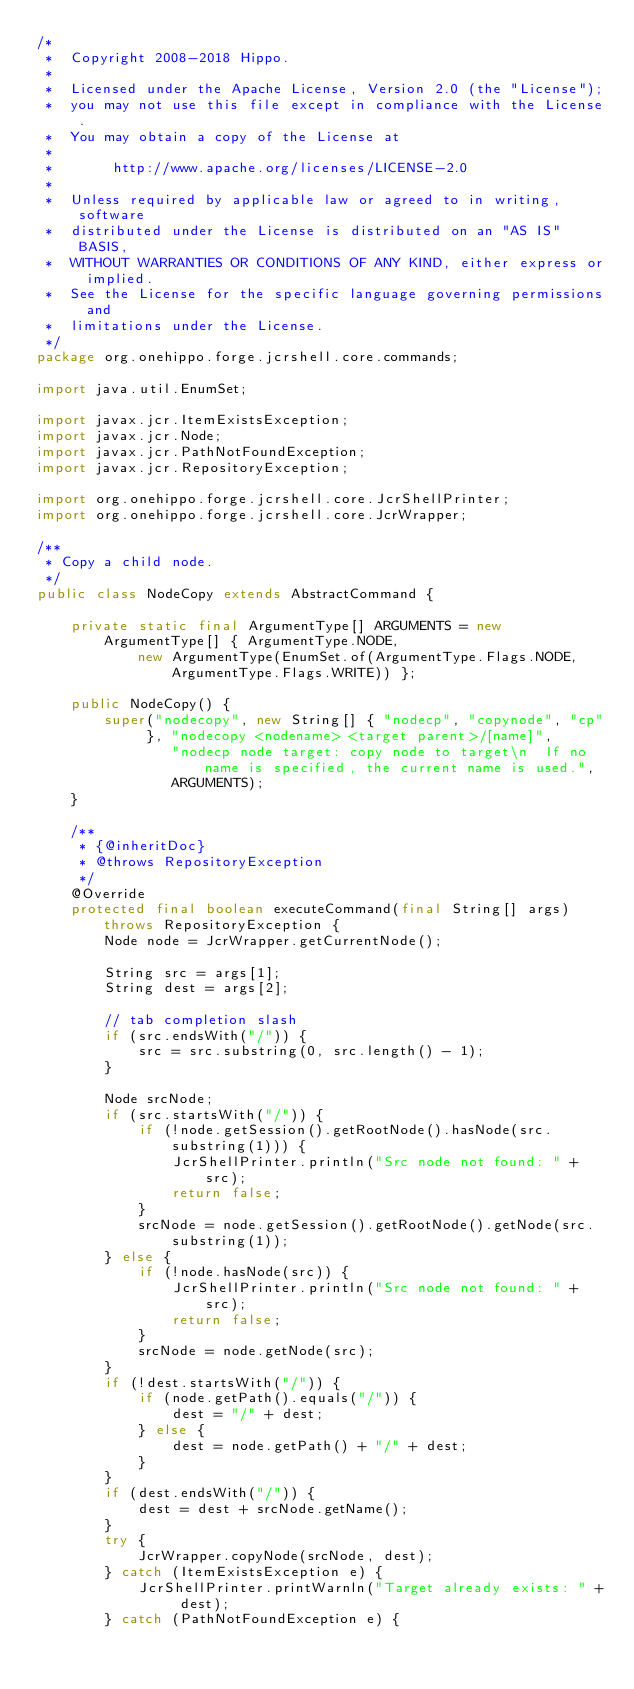<code> <loc_0><loc_0><loc_500><loc_500><_Java_>/*
 *  Copyright 2008-2018 Hippo.
 *
 *  Licensed under the Apache License, Version 2.0 (the "License");
 *  you may not use this file except in compliance with the License.
 *  You may obtain a copy of the License at
 *
 *       http://www.apache.org/licenses/LICENSE-2.0
 *
 *  Unless required by applicable law or agreed to in writing, software
 *  distributed under the License is distributed on an "AS IS" BASIS,
 *  WITHOUT WARRANTIES OR CONDITIONS OF ANY KIND, either express or implied.
 *  See the License for the specific language governing permissions and
 *  limitations under the License.
 */
package org.onehippo.forge.jcrshell.core.commands;

import java.util.EnumSet;

import javax.jcr.ItemExistsException;
import javax.jcr.Node;
import javax.jcr.PathNotFoundException;
import javax.jcr.RepositoryException;

import org.onehippo.forge.jcrshell.core.JcrShellPrinter;
import org.onehippo.forge.jcrshell.core.JcrWrapper;

/**
 * Copy a child node.
 */
public class NodeCopy extends AbstractCommand {

    private static final ArgumentType[] ARGUMENTS = new ArgumentType[] { ArgumentType.NODE,
            new ArgumentType(EnumSet.of(ArgumentType.Flags.NODE, ArgumentType.Flags.WRITE)) };

    public NodeCopy() {
        super("nodecopy", new String[] { "nodecp", "copynode", "cp" }, "nodecopy <nodename> <target parent>/[name]",
                "nodecp node target: copy node to target\n  If no name is specified, the current name is used.",
                ARGUMENTS);
    }

    /**
     * {@inheritDoc}
     * @throws RepositoryException 
     */
    @Override
    protected final boolean executeCommand(final String[] args) throws RepositoryException {
        Node node = JcrWrapper.getCurrentNode();

        String src = args[1];
        String dest = args[2];

        // tab completion slash
        if (src.endsWith("/")) {
            src = src.substring(0, src.length() - 1);
        }

        Node srcNode;
        if (src.startsWith("/")) {
            if (!node.getSession().getRootNode().hasNode(src.substring(1))) {
                JcrShellPrinter.println("Src node not found: " + src);
                return false;
            }
            srcNode = node.getSession().getRootNode().getNode(src.substring(1));
        } else {
            if (!node.hasNode(src)) {
                JcrShellPrinter.println("Src node not found: " + src);
                return false;
            }
            srcNode = node.getNode(src);
        }
        if (!dest.startsWith("/")) {
            if (node.getPath().equals("/")) {
                dest = "/" + dest;
            } else {
                dest = node.getPath() + "/" + dest;
            }
        }
        if (dest.endsWith("/")) {
            dest = dest + srcNode.getName();
        }
        try {
            JcrWrapper.copyNode(srcNode, dest);
        } catch (ItemExistsException e) {
            JcrShellPrinter.printWarnln("Target already exists: " + dest);
        } catch (PathNotFoundException e) {</code> 